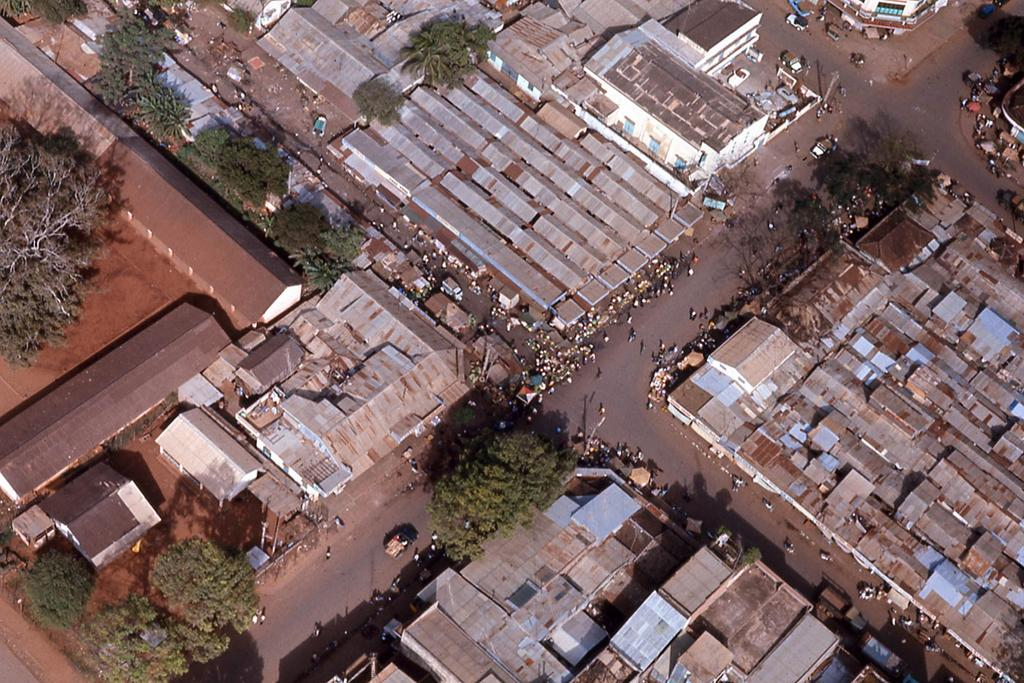What type of structures can be seen in the image? There are houses in the image. What other natural elements are present in the image? There are trees in the image. What types of man-made objects can be seen in the image? There are vehicles in the image. Are there any living beings visible in the image? Yes, there are people in the image. What type of shirt is the time wearing in the image? There is no time or shirt present in the image. How does the twist interact with the people in the image? There is no twist present in the image; it is not interacting with the people. 